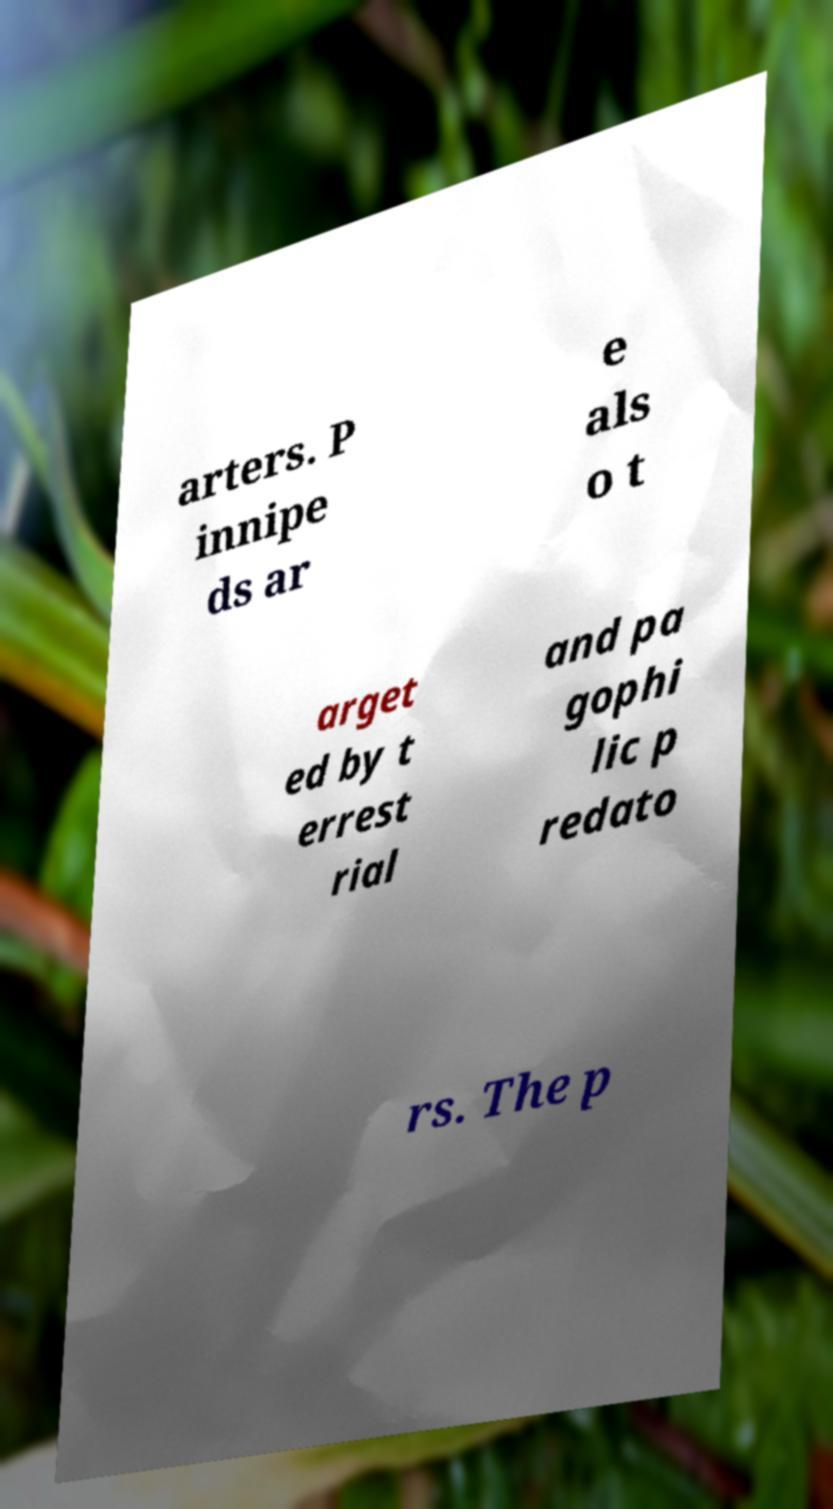I need the written content from this picture converted into text. Can you do that? arters. P innipe ds ar e als o t arget ed by t errest rial and pa gophi lic p redato rs. The p 